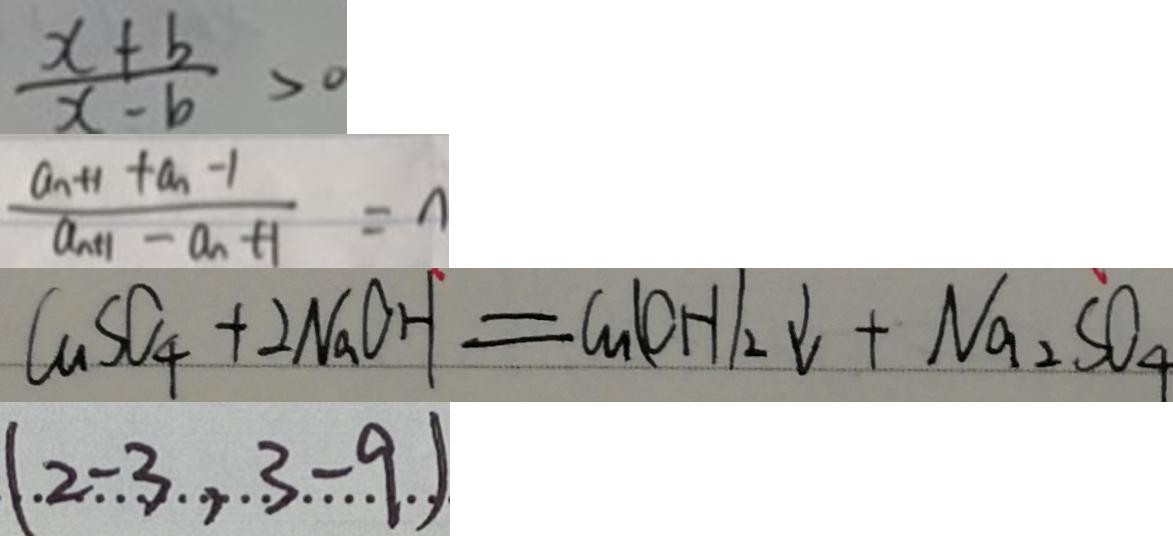Convert formula to latex. <formula><loc_0><loc_0><loc_500><loc_500>\frac { x + b } { x - b } > 0 
 \frac { a _ { n + 1 } + a _ { n - 1 } } { a _ { n + 1 } - a _ { n } + 1 } = n 
 C u S O _ { 4 } + 2 N a O H = G u ( O H ) _ { 2 } \downarrow + N a _ { 2 } S O _ { 4 } 
 ( 2 - 3 , 3 - 9 )</formula> 